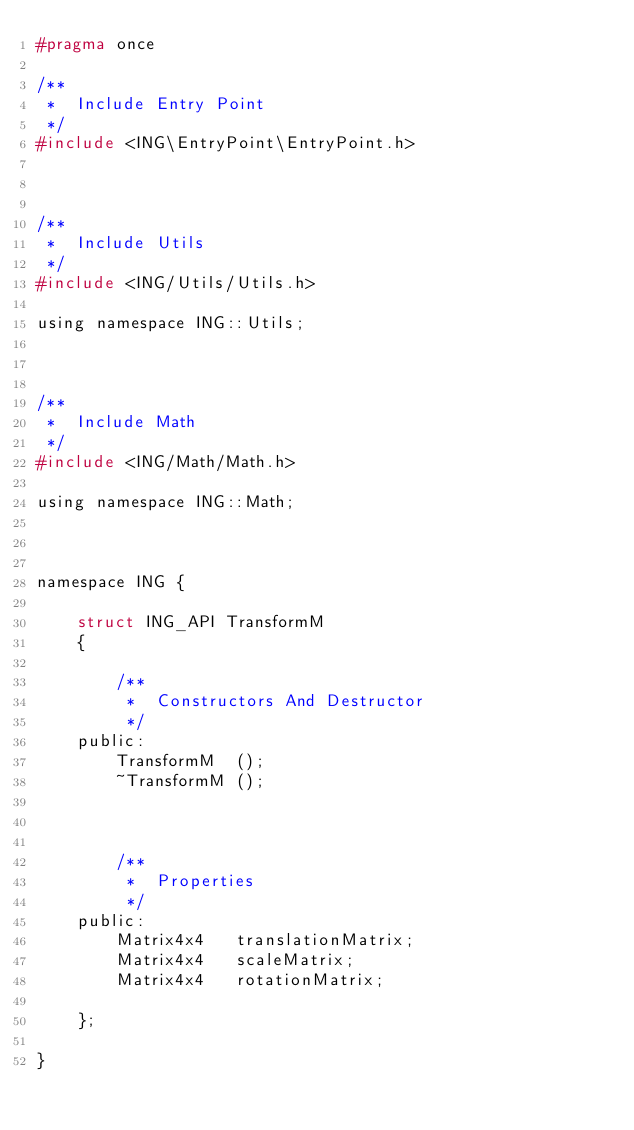<code> <loc_0><loc_0><loc_500><loc_500><_C_>#pragma once

/**
 *	Include Entry Point
 */
#include <ING\EntryPoint\EntryPoint.h>



/**
 *	Include Utils
 */
#include <ING/Utils/Utils.h>

using namespace ING::Utils;



/**
 *	Include Math
 */
#include <ING/Math/Math.h>

using namespace ING::Math;



namespace ING {

	struct ING_API TransformM
	{

		/**
		 *	Constructors And Destructor
		 */
	public:
		TransformM	();
		~TransformM	();



		/**
		 *	Properties
		 */
	public:
		Matrix4x4	translationMatrix;
		Matrix4x4	scaleMatrix;
		Matrix4x4	rotationMatrix;

	};

}</code> 